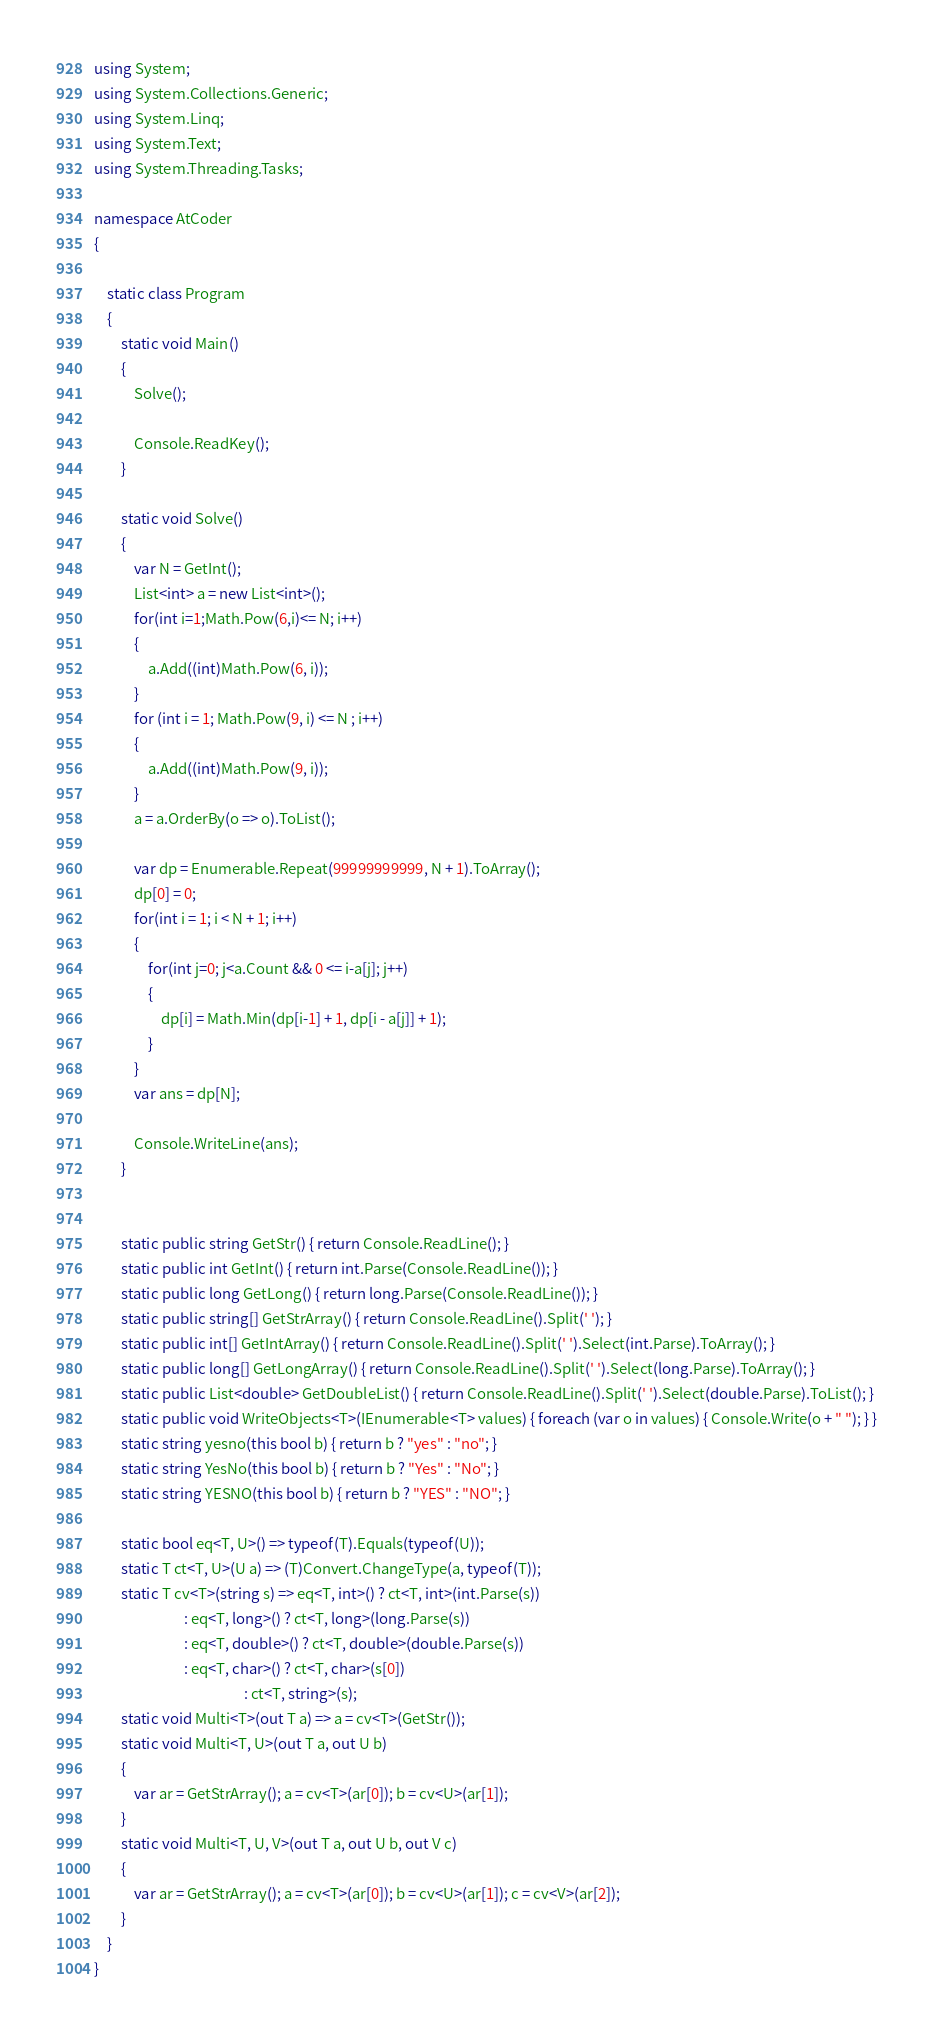Convert code to text. <code><loc_0><loc_0><loc_500><loc_500><_C#_>using System;
using System.Collections.Generic;
using System.Linq;
using System.Text;
using System.Threading.Tasks;

namespace AtCoder
{

    static class Program
    {
        static void Main()
        {
            Solve();

            Console.ReadKey();
        }

        static void Solve()
        {
            var N = GetInt();
            List<int> a = new List<int>();
            for(int i=1;Math.Pow(6,i)<= N; i++)
            {
                a.Add((int)Math.Pow(6, i));
            }
            for (int i = 1; Math.Pow(9, i) <= N ; i++)
            {
                a.Add((int)Math.Pow(9, i));
            }
            a = a.OrderBy(o => o).ToList();

            var dp = Enumerable.Repeat(99999999999, N + 1).ToArray();
            dp[0] = 0;
            for(int i = 1; i < N + 1; i++)
            {
                for(int j=0; j<a.Count && 0 <= i-a[j]; j++)
                {
                    dp[i] = Math.Min(dp[i-1] + 1, dp[i - a[j]] + 1);
                }
            }
            var ans = dp[N];

            Console.WriteLine(ans); 
        }


        static public string GetStr() { return Console.ReadLine(); }
        static public int GetInt() { return int.Parse(Console.ReadLine()); }
        static public long GetLong() { return long.Parse(Console.ReadLine()); }
        static public string[] GetStrArray() { return Console.ReadLine().Split(' '); }
        static public int[] GetIntArray() { return Console.ReadLine().Split(' ').Select(int.Parse).ToArray(); }
        static public long[] GetLongArray() { return Console.ReadLine().Split(' ').Select(long.Parse).ToArray(); }
        static public List<double> GetDoubleList() { return Console.ReadLine().Split(' ').Select(double.Parse).ToList(); }
        static public void WriteObjects<T>(IEnumerable<T> values) { foreach (var o in values) { Console.Write(o + " "); } }
        static string yesno(this bool b) { return b ? "yes" : "no"; }
        static string YesNo(this bool b) { return b ? "Yes" : "No"; }
        static string YESNO(this bool b) { return b ? "YES" : "NO"; }

        static bool eq<T, U>() => typeof(T).Equals(typeof(U));
        static T ct<T, U>(U a) => (T)Convert.ChangeType(a, typeof(T));
        static T cv<T>(string s) => eq<T, int>() ? ct<T, int>(int.Parse(s))
                           : eq<T, long>() ? ct<T, long>(long.Parse(s))
                           : eq<T, double>() ? ct<T, double>(double.Parse(s))
                           : eq<T, char>() ? ct<T, char>(s[0])
                                             : ct<T, string>(s);
        static void Multi<T>(out T a) => a = cv<T>(GetStr());
        static void Multi<T, U>(out T a, out U b)
        {
            var ar = GetStrArray(); a = cv<T>(ar[0]); b = cv<U>(ar[1]);
        }
        static void Multi<T, U, V>(out T a, out U b, out V c)
        {
            var ar = GetStrArray(); a = cv<T>(ar[0]); b = cv<U>(ar[1]); c = cv<V>(ar[2]);
        }
    }
}</code> 